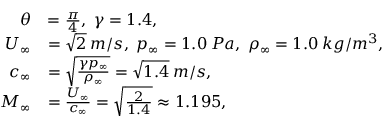Convert formula to latex. <formula><loc_0><loc_0><loc_500><loc_500>\begin{array} { r l } { \theta } & { = \frac { \pi } { 4 } , \, \gamma = 1 . 4 , } \\ { U _ { \infty } } & { = \sqrt { 2 } \, m / s , \, p _ { \infty } = 1 . 0 \, P a , \, \rho _ { \infty } = 1 . 0 \, k g / m ^ { 3 } , } \\ { c _ { \infty } } & { = \sqrt { \frac { \gamma p _ { \infty } } { \rho _ { \infty } } } = \sqrt { 1 . 4 } \, m / s , } \\ { M _ { \infty } } & { = \frac { U _ { \infty } } { c _ { \infty } } = \sqrt { \frac { 2 } { 1 . 4 } } \approx 1 . 1 9 5 , } \end{array}</formula> 